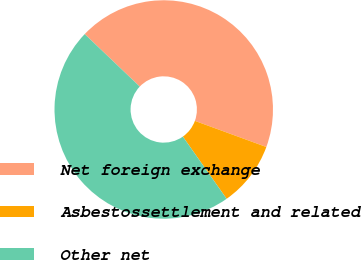<chart> <loc_0><loc_0><loc_500><loc_500><pie_chart><fcel>Net foreign exchange<fcel>Asbestossettlement and related<fcel>Other net<nl><fcel>43.46%<fcel>9.66%<fcel>46.89%<nl></chart> 